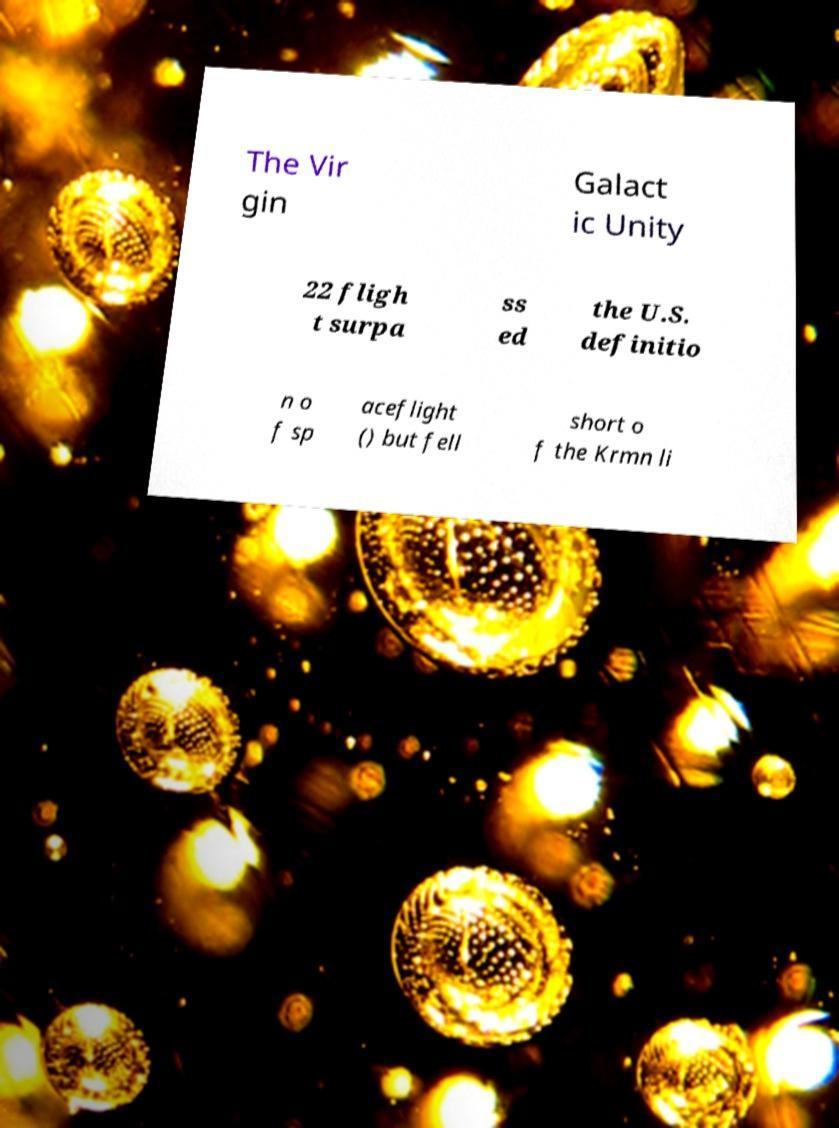I need the written content from this picture converted into text. Can you do that? The Vir gin Galact ic Unity 22 fligh t surpa ss ed the U.S. definitio n o f sp aceflight () but fell short o f the Krmn li 